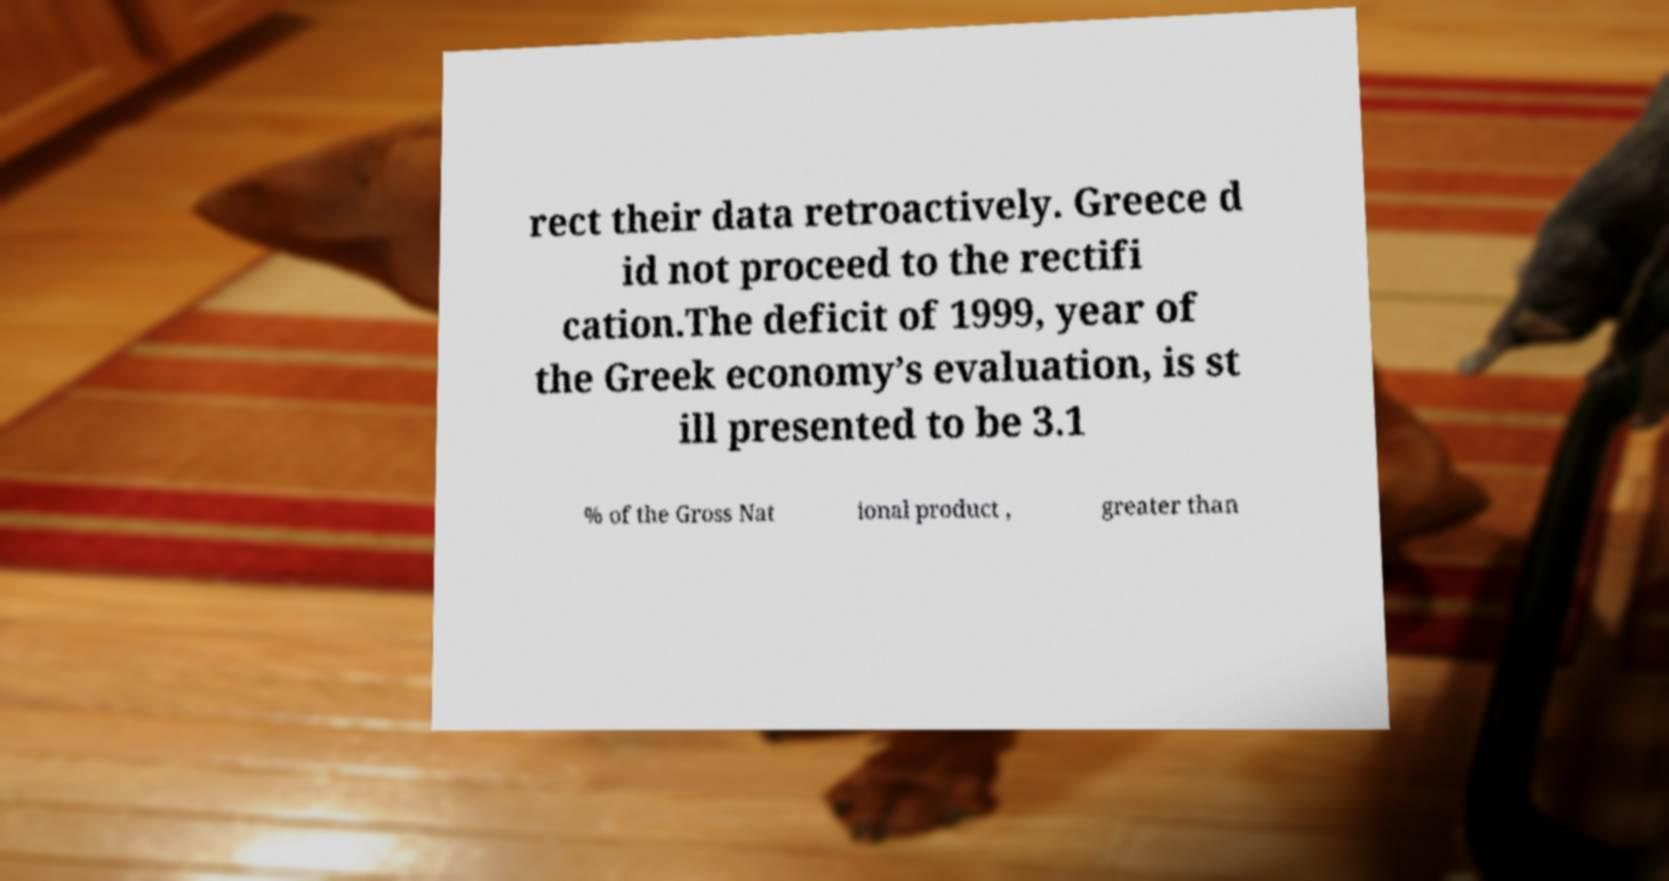What messages or text are displayed in this image? I need them in a readable, typed format. rect their data retroactively. Greece d id not proceed to the rectifi cation.The deficit of 1999, year of the Greek economy’s evaluation, is st ill presented to be 3.1 % of the Gross Nat ional product , greater than 